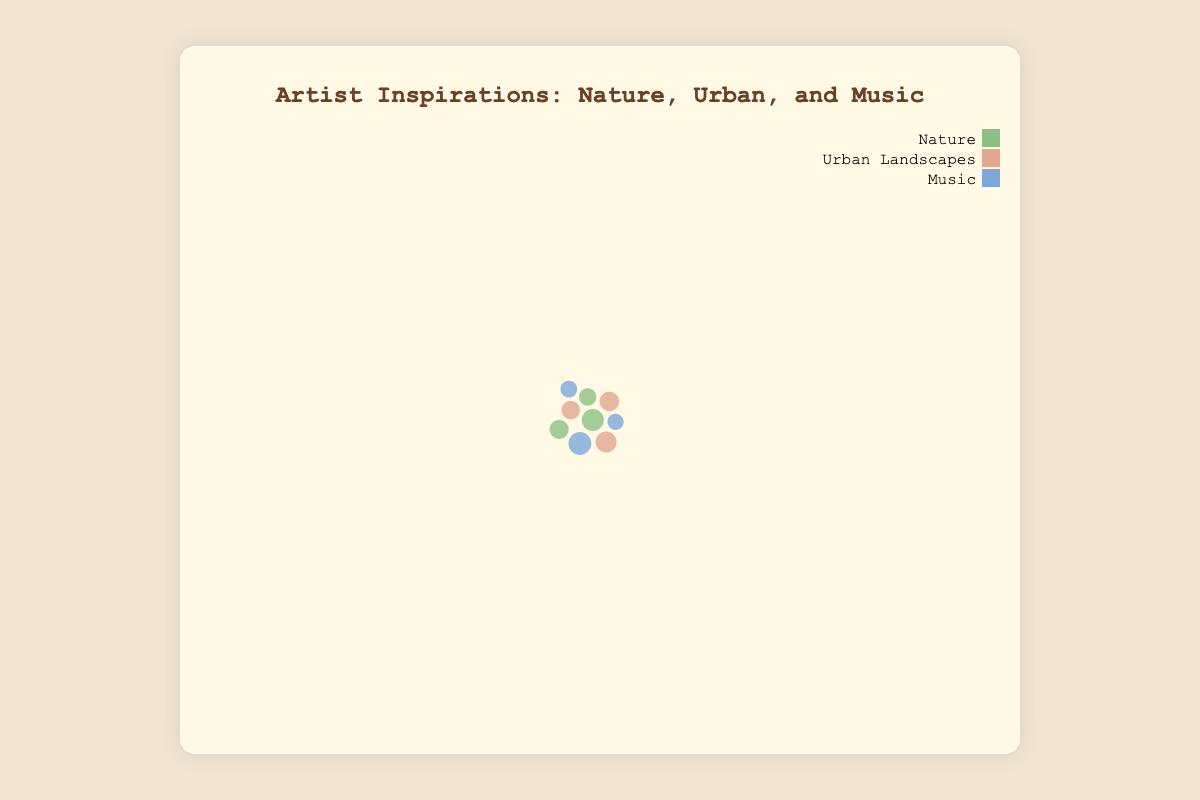What title is displayed on the chart? The title can be found at the top of the chart within the chart-container. It reads "Artist Inspirations: Nature, Urban, and Music."
Answer: Artist Inspirations: Nature, Urban, and Music How many different source types are represented in the chart? By examining the bubbles and the legend, we can see the colors representing three source types: Nature, Urban Landscapes, and Music.
Answer: 3 Which specific source has the highest number of inspiration instances? By comparing the size of the bubbles, the bubble for "Jazz" in the Music category is the largest, indicating the highest number of inspiration instances.
Answer: Jazz What are the x and y coordinates that the force simulation brings bubbles towards? In the code, the forceX and forceY centers are set at half the width and height of the svg, corresponding to (400, 300). By looking at the placement, this is where bubbles converge during simulation.
Answer: (400, 300) Which source type has the most artists? By observing the tooltip on hover and comparing artist counts, the Jazz from the Music category has the most artists with 50.
Answer: Music (Jazz) Compare the number of inspiration instances between ‘Forest’ and ‘City Streets.’ Which one is greater, and by how much? Forest has 120 inspiration instances while City Streets have 110. The difference is 120 - 110 = 10, so Forest has 10 more inspiration instances.
Answer: Forest, by 10 What is the average number of artists for Urban Landscapes sources? Urban Landscapes include City Streets (40), Buildings (30), and Parks (33). The sum is 40 + 30 + 33 = 103. The average is 103 / 3 = 34.33.
Answer: 34.33 Which specific source has the smallest bubble? The smallest bubble corresponds to Rock within the Music category, indicating it has the fewest inspiration instances.
Answer: Rock Arrange the specific sources in descending order of the number of inspiration instances. Sorting by bubble size: Jazz (130), Forest (120), City Streets (110), Parks (95), Ocean (90), Buildings (85), Mountains (75), Classical (70), Rock (65).
Answer: Jazz, Forest, City Streets, Parks, Ocean, Buildings, Mountains, Classical, Rock What color represents the 'Urban Landscapes' category in the chart? By looking at the legend along with the bubbles, Urban Landscapes is represented by a pale orange color.
Answer: Pale orange 